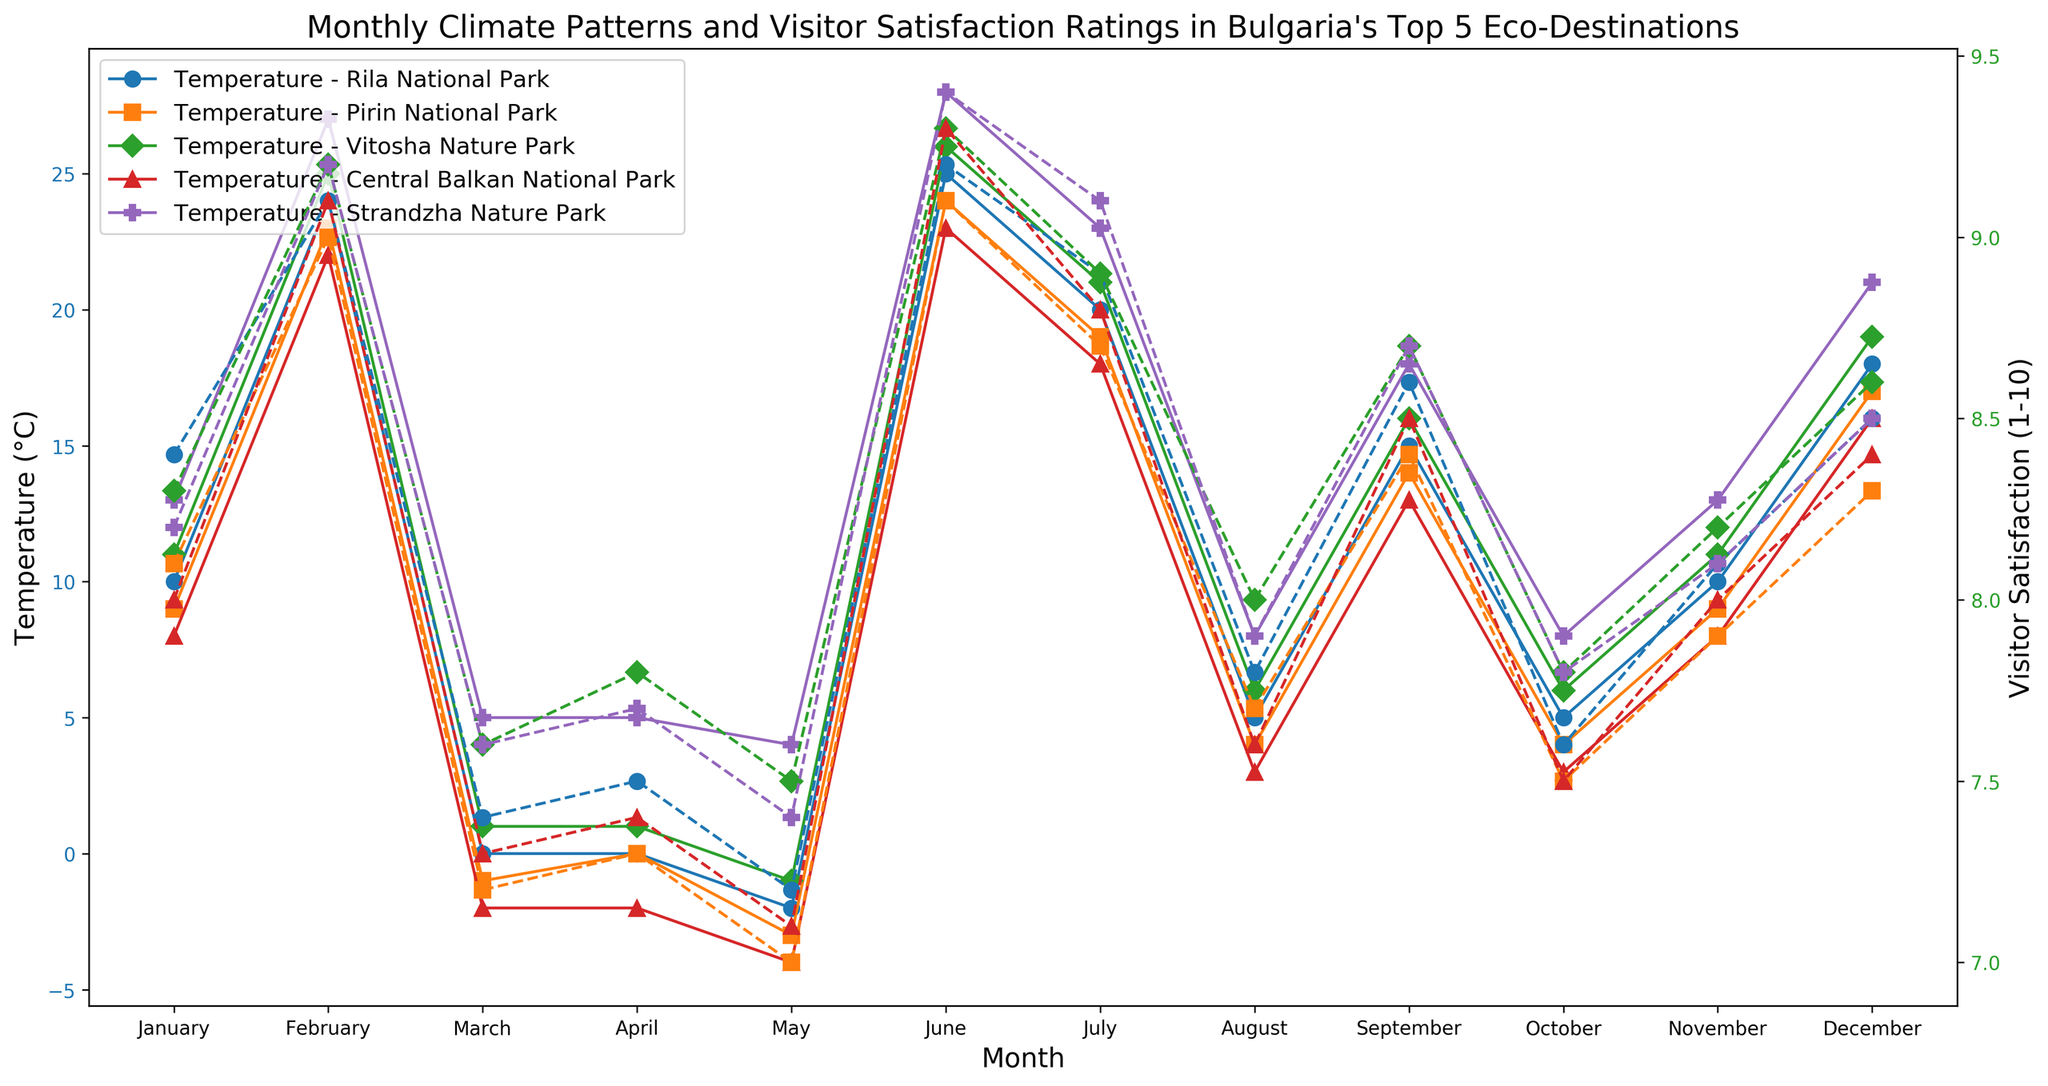What's the average Visitor Satisfaction Rating in June across all destinations? To answer this, we need to first identify the Visitor Satisfaction Ratings in June for all five destinations. They are: Rila National Park (8.9), Pirin National Park (8.7), Vitosha Nature Park (8.9), Central Balkan National Park (8.8), Strandzha Nature Park (9.1). Add these values and divide by 5. (8.9 + 8.7 + 8.9 + 8.8 + 9.1) / 5 = 8.88.
Answer: 8.88 Which destination has the highest temperature in July, and what is the Visitor Satisfaction Rating for that destination in the same month? In July, manually check the temperature for all destinations. Strandzha Nature Park has the highest temperature of 28°C. Check the corresponding Visitor Satisfaction Rating for Strandzha Nature Park in July, which is 9.4.
Answer: Strandzha Nature Park, 9.4 How does the Visitor Satisfaction Rating correlate with the temperature change in Vitosha Nature Park from January to December? Check the Temperature and Visitor Satisfaction for each month of Vitosha Nature Park. Notice the trend that as temperature increases from January (-1°C) to July (26°C), the Visitor Satisfaction Rating also increases from 7.5 to 9.3 and then slightly decreases as Temperature drops towards December (1°C, 7.6). Therefore, generally, an increase in temperature correlates with higher Visitor Satisfaction Ratings.
Answer: Positive correlation Which month shows the highest precipitation in Central Balkan National Park, and what is the Visitor Satisfaction Rating in that month? Identify months and their precipitation values for Central Balkan National Park. June has the highest precipitation of 120mm. The Visitor Satisfaction Rating for June is 8.8.
Answer: June, 8.8 Compare the Visitor Satisfaction Ratings between Rila National Park and Pirin National Park in August. Which park has a higher rating and by how much? In August, Rila National Park has a rating of 9.1 and Pirin National Park has a rating of 9.0. Subtracting the two: 9.1 - 9.0 = 0.1. Rila National Park has a higher rating by 0.1.
Answer: Rila National Park, 0.1 What's the difference in average temperatures between January and June across all destinations? For each destination in January, note the temperatures: Rila National Park (-2°C), Pirin National Park (-3°C), Vitosha Nature Park (-1°C), Central Balkan National Park (-4°C), Strandzha Nature Park (4°C). Average = (-2 - 3 - 1 - 4 + 4)/5 = -1.2°C. For June: Rila National Park (20°C), Pirin National Park (19°C), Vitosha Nature Park (21°C), Central Balkan National Park (18°C), Strandzha Nature Park (23°C). Average = (20 + 19 + 21 + 18 + 23)/5 = 20.2°C. The difference = 20.2 - (-1.2) = 21.4°C.
Answer: 21.4°C In which month does Vitosha Nature Park have the lowest Visitor Satisfaction Rating, and what is the corresponding temperature and precipitation in that month? Check Visitor Satisfaction Ratings for Vitosha Nature Park across all months. January has the lowest rating at 7.5. The temperature in January is -1°C, and precipitation is 70mm.
Answer: January, -1°C, 70mm 